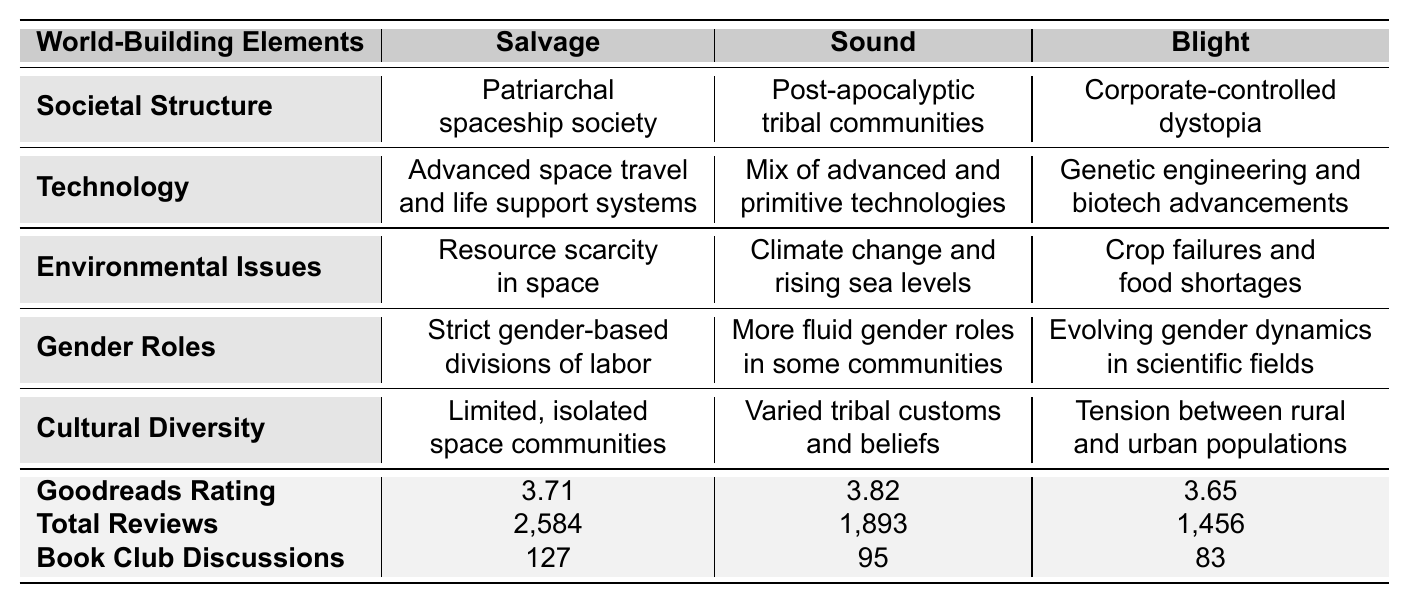What is the societal structure in "Sound"? The table indicates that "Sound" features a post-apocalyptic tribal community as its societal structure. This is found in the row for "Societal Structure" under the column for "Sound."
Answer: Post-apocalyptic tribal communities Which novel has the highest Goodreads rating? The Goodreads ratings in the table show that "Sound" has the highest rating at 3.82, which is compared with the ratings of "Salvage" (3.71) and "Blight" (3.65).
Answer: Sound What is the primary environmental issue addressed in "Blight"? By looking at the "Environmental Issues" row under the "Blight" column, it specifies that the primary environmental issue is crop failures and food shortages.
Answer: Crop failures and food shortages How does the cultural diversity in "Salvage" compare to "Blight"? The table shows that "Salvage" has limited, isolated space communities, while "Blight" features tension between rural and urban populations. This implies that "Blight" presents a broader view of cultural diversity compared to "Salvage."
Answer: Blight presents broader diversity What is the difference in total reviews between "Salvage" and "Blight"? The total reviews indicate that "Salvage" has 2,584 reviews, whereas "Blight" has 1,456. Calculating the difference gives 2,584 - 1,456 = 1,128.
Answer: 1,128 Which novel addresses the theme of female empowerment, and what is its societal structure? The table does not explicitly link the themes to the societal structures, but female empowerment is a theme present in all novels. Among them, "Sound" features more fluid gender roles in its post-apocalyptic tribal communities, indicating a natural association.
Answer: Sound; post-apocalyptic tribal communities Based on the provided data, what can you infer about the gender roles in "Sound" compared to "Salvage"? In "Sound," gender roles are described as more fluid in some communities, while "Salvage" has strict gender-based divisions of labor, suggesting that "Sound" offers more progressive views on gender.
Answer: Sound has more fluid gender roles What is the average Goodreads rating of the three novels? To find the average rating: (3.71 + 3.82 + 3.65) / 3 = 11.18 / 3 = approximately 3.73. The step involves summing each rating and dividing by the number of novels.
Answer: 3.73 